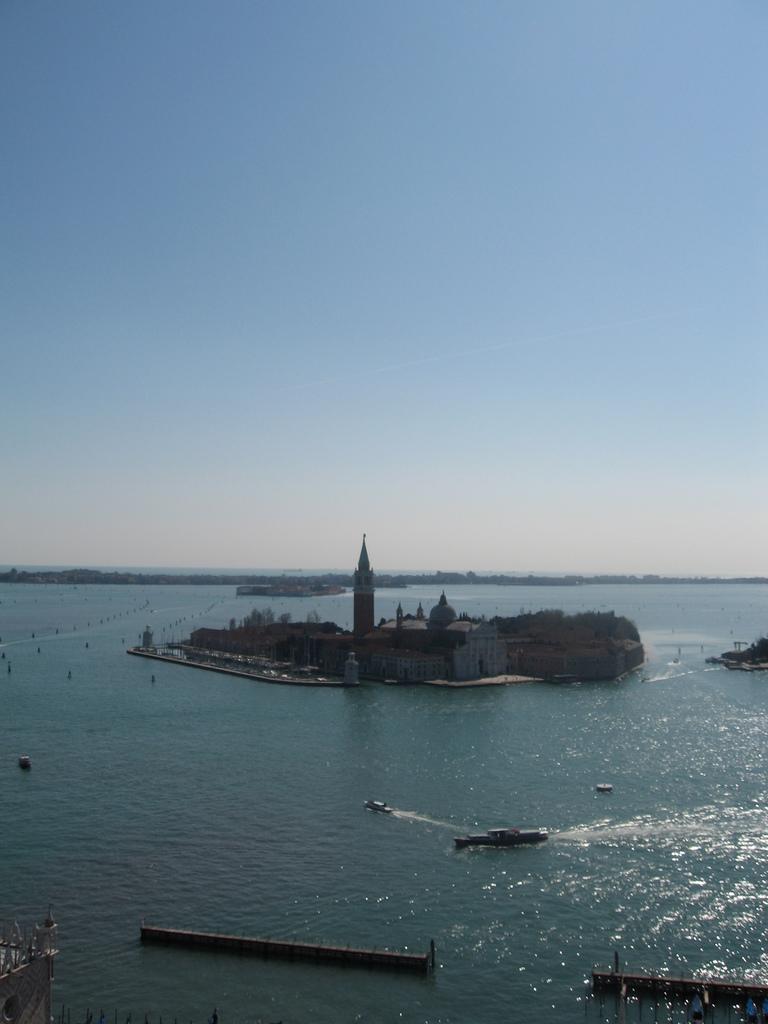Describe this image in one or two sentences. In the foreground and in the background we can see a water body. In the center of the picture there is an island in which we can see castle and trees. In the water there are boats and other objects. At the top it is sky. At the bottom left corner it is looking like a building. 